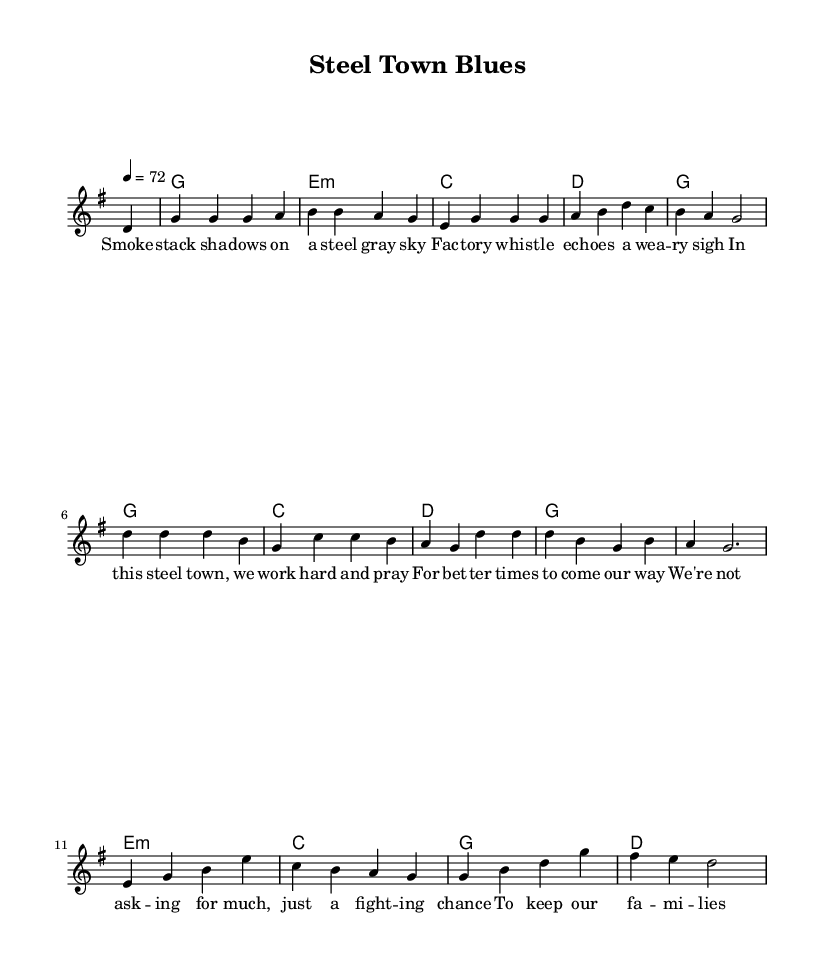What is the key signature of this music? The key signature is indicated by the notation at the beginning of the sheet music. It shows one sharp, which aligns with the G major scale.
Answer: G major What is the time signature of this music? The time signature is noted in the beginning before the melody starts. It shows 4/4, meaning there are four beats in each measure.
Answer: 4/4 What is the tempo of this music? The tempo is indicated at the beginning with '4 = 72', which means the quarter note is set to a speed of 72 beats per minute.
Answer: 72 How many phrases are there in the melody? The melody has multiple phrases, and you can identify them by the rests and punctuation in the musical line. Counting all the phrases, it totals four distinct sections.
Answer: Four What is the emotional theme of the lyrics? The lyrics reflect themes of struggle and hope, commonly found in modern country ballads. Analyzing the phrases reveals a focus on hard work and the desire for a better future.
Answer: Struggle and hope What chord accompanies the first phrase of the melody? The first melody note starts with a D note, and the harmonies indicate that it begins with a G chord, which supports that initial phrase.
Answer: G What type of chord is played after the third line of lyrics? Upon reviewing the harmonies section, after the third line of lyrics, the chord played is E minor, indicated in the chord progression.
Answer: E minor 